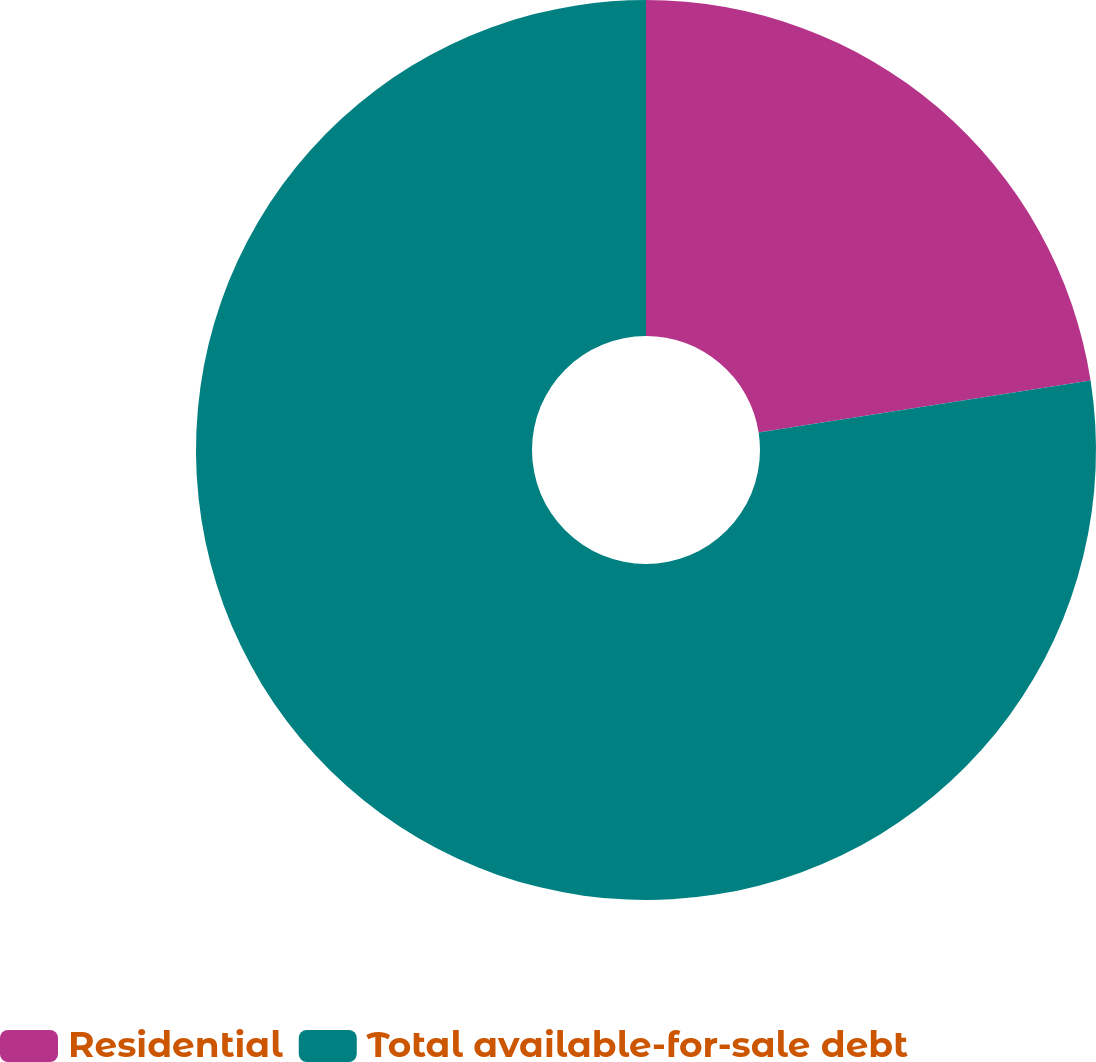Convert chart. <chart><loc_0><loc_0><loc_500><loc_500><pie_chart><fcel>Residential<fcel>Total available-for-sale debt<nl><fcel>22.53%<fcel>77.47%<nl></chart> 